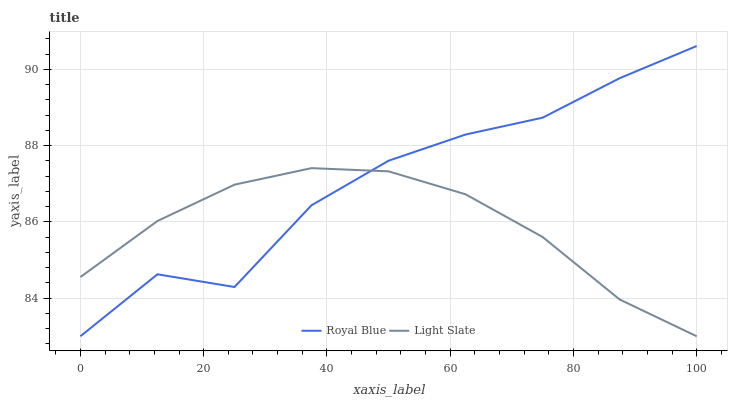Does Royal Blue have the minimum area under the curve?
Answer yes or no. No. Is Royal Blue the smoothest?
Answer yes or no. No. 